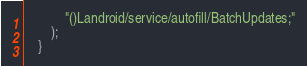Convert code to text. <code><loc_0><loc_0><loc_500><loc_500><_C++_>			"()Landroid/service/autofill/BatchUpdates;"
		);
	}</code> 